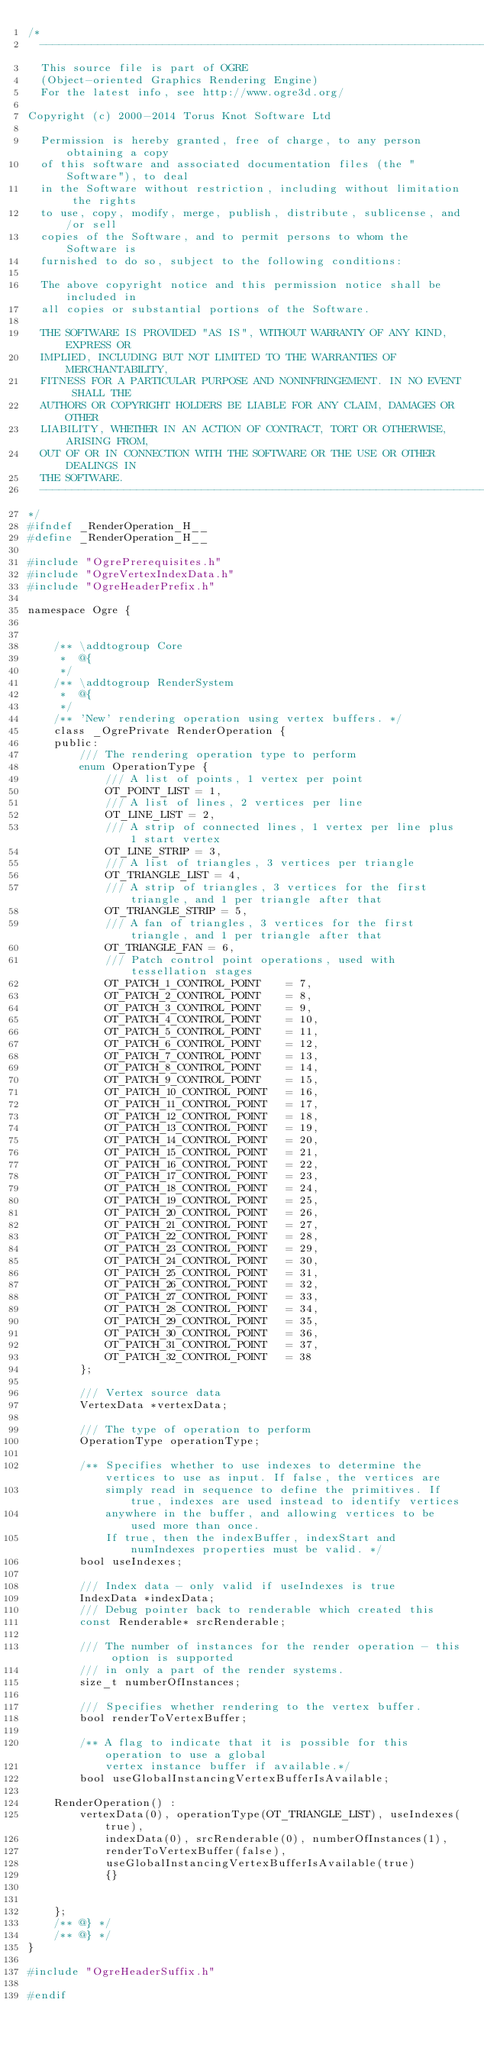Convert code to text. <code><loc_0><loc_0><loc_500><loc_500><_C_>/*
  -----------------------------------------------------------------------------
  This source file is part of OGRE
  (Object-oriented Graphics Rendering Engine)
  For the latest info, see http://www.ogre3d.org/

Copyright (c) 2000-2014 Torus Knot Software Ltd

  Permission is hereby granted, free of charge, to any person obtaining a copy
  of this software and associated documentation files (the "Software"), to deal
  in the Software without restriction, including without limitation the rights
  to use, copy, modify, merge, publish, distribute, sublicense, and/or sell
  copies of the Software, and to permit persons to whom the Software is
  furnished to do so, subject to the following conditions:

  The above copyright notice and this permission notice shall be included in
  all copies or substantial portions of the Software.

  THE SOFTWARE IS PROVIDED "AS IS", WITHOUT WARRANTY OF ANY KIND, EXPRESS OR
  IMPLIED, INCLUDING BUT NOT LIMITED TO THE WARRANTIES OF MERCHANTABILITY,
  FITNESS FOR A PARTICULAR PURPOSE AND NONINFRINGEMENT. IN NO EVENT SHALL THE
  AUTHORS OR COPYRIGHT HOLDERS BE LIABLE FOR ANY CLAIM, DAMAGES OR OTHER
  LIABILITY, WHETHER IN AN ACTION OF CONTRACT, TORT OR OTHERWISE, ARISING FROM,
  OUT OF OR IN CONNECTION WITH THE SOFTWARE OR THE USE OR OTHER DEALINGS IN
  THE SOFTWARE.
  -----------------------------------------------------------------------------
*/
#ifndef _RenderOperation_H__
#define _RenderOperation_H__

#include "OgrePrerequisites.h"
#include "OgreVertexIndexData.h"
#include "OgreHeaderPrefix.h"

namespace Ogre {


    /** \addtogroup Core
     *  @{
     */
    /** \addtogroup RenderSystem
     *  @{
     */
    /** 'New' rendering operation using vertex buffers. */
    class _OgrePrivate RenderOperation {
    public:
        /// The rendering operation type to perform
        enum OperationType {
            /// A list of points, 1 vertex per point
            OT_POINT_LIST = 1,
            /// A list of lines, 2 vertices per line
            OT_LINE_LIST = 2,
            /// A strip of connected lines, 1 vertex per line plus 1 start vertex
            OT_LINE_STRIP = 3,
            /// A list of triangles, 3 vertices per triangle
            OT_TRIANGLE_LIST = 4,
            /// A strip of triangles, 3 vertices for the first triangle, and 1 per triangle after that
            OT_TRIANGLE_STRIP = 5,
            /// A fan of triangles, 3 vertices for the first triangle, and 1 per triangle after that
            OT_TRIANGLE_FAN = 6,
            /// Patch control point operations, used with tessellation stages
            OT_PATCH_1_CONTROL_POINT    = 7,
            OT_PATCH_2_CONTROL_POINT    = 8,
            OT_PATCH_3_CONTROL_POINT    = 9,
            OT_PATCH_4_CONTROL_POINT    = 10,
            OT_PATCH_5_CONTROL_POINT    = 11,
            OT_PATCH_6_CONTROL_POINT    = 12,
            OT_PATCH_7_CONTROL_POINT    = 13,
            OT_PATCH_8_CONTROL_POINT    = 14,
            OT_PATCH_9_CONTROL_POINT    = 15,
            OT_PATCH_10_CONTROL_POINT   = 16,
            OT_PATCH_11_CONTROL_POINT   = 17,
            OT_PATCH_12_CONTROL_POINT   = 18,
            OT_PATCH_13_CONTROL_POINT   = 19,
            OT_PATCH_14_CONTROL_POINT   = 20,
            OT_PATCH_15_CONTROL_POINT   = 21,
            OT_PATCH_16_CONTROL_POINT   = 22,
            OT_PATCH_17_CONTROL_POINT   = 23,
            OT_PATCH_18_CONTROL_POINT   = 24,
            OT_PATCH_19_CONTROL_POINT   = 25,
            OT_PATCH_20_CONTROL_POINT   = 26,
            OT_PATCH_21_CONTROL_POINT   = 27,
            OT_PATCH_22_CONTROL_POINT   = 28,
            OT_PATCH_23_CONTROL_POINT   = 29,
            OT_PATCH_24_CONTROL_POINT   = 30,
            OT_PATCH_25_CONTROL_POINT   = 31,
            OT_PATCH_26_CONTROL_POINT   = 32,
            OT_PATCH_27_CONTROL_POINT   = 33,
            OT_PATCH_28_CONTROL_POINT   = 34,
            OT_PATCH_29_CONTROL_POINT   = 35,
            OT_PATCH_30_CONTROL_POINT   = 36,
            OT_PATCH_31_CONTROL_POINT   = 37,
            OT_PATCH_32_CONTROL_POINT   = 38
        };

        /// Vertex source data
        VertexData *vertexData;

        /// The type of operation to perform
        OperationType operationType;

        /** Specifies whether to use indexes to determine the vertices to use as input. If false, the vertices are
            simply read in sequence to define the primitives. If true, indexes are used instead to identify vertices
            anywhere in the buffer, and allowing vertices to be used more than once.
            If true, then the indexBuffer, indexStart and numIndexes properties must be valid. */
        bool useIndexes;

        /// Index data - only valid if useIndexes is true
        IndexData *indexData;
        /// Debug pointer back to renderable which created this
        const Renderable* srcRenderable;

        /// The number of instances for the render operation - this option is supported
        /// in only a part of the render systems.
        size_t numberOfInstances;

        /// Specifies whether rendering to the vertex buffer.
        bool renderToVertexBuffer;

        /** A flag to indicate that it is possible for this operation to use a global
            vertex instance buffer if available.*/
        bool useGlobalInstancingVertexBufferIsAvailable;

    RenderOperation() :
        vertexData(0), operationType(OT_TRIANGLE_LIST), useIndexes(true),
            indexData(0), srcRenderable(0), numberOfInstances(1),
            renderToVertexBuffer(false),
            useGlobalInstancingVertexBufferIsAvailable(true)
            {}


    };
    /** @} */
    /** @} */
}

#include "OgreHeaderSuffix.h"

#endif
</code> 